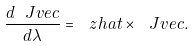<formula> <loc_0><loc_0><loc_500><loc_500>\frac { d \ J v e c } { d \lambda } = \ z h a t \times \ J v e c .</formula> 